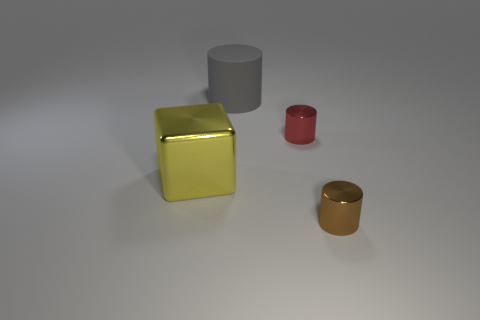There is a big thing that is on the left side of the big rubber cylinder; is it the same shape as the tiny object to the right of the red cylinder?
Make the answer very short. No. Are there any brown cylinders that have the same material as the large yellow block?
Ensure brevity in your answer.  Yes. What color is the small metal cylinder that is in front of the tiny thing that is left of the small cylinder that is in front of the tiny red cylinder?
Ensure brevity in your answer.  Brown. Does the large thing behind the large yellow thing have the same material as the small object that is behind the brown metallic thing?
Ensure brevity in your answer.  No. The big object that is to the right of the large yellow cube has what shape?
Ensure brevity in your answer.  Cylinder. What number of things are tiny cylinders or big things that are to the left of the large gray rubber thing?
Provide a succinct answer. 3. Are the gray cylinder and the big yellow cube made of the same material?
Ensure brevity in your answer.  No. Are there an equal number of tiny metal things that are behind the small red thing and small brown cylinders left of the yellow metallic block?
Offer a very short reply. Yes. There is a brown thing; how many red objects are on the right side of it?
Provide a succinct answer. 0. How many things are either red shiny objects or big yellow metal cubes?
Ensure brevity in your answer.  2. 